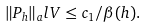<formula> <loc_0><loc_0><loc_500><loc_500>\| P _ { h } \| _ { a } l V \leq c _ { 1 } / \beta ( h ) .</formula> 